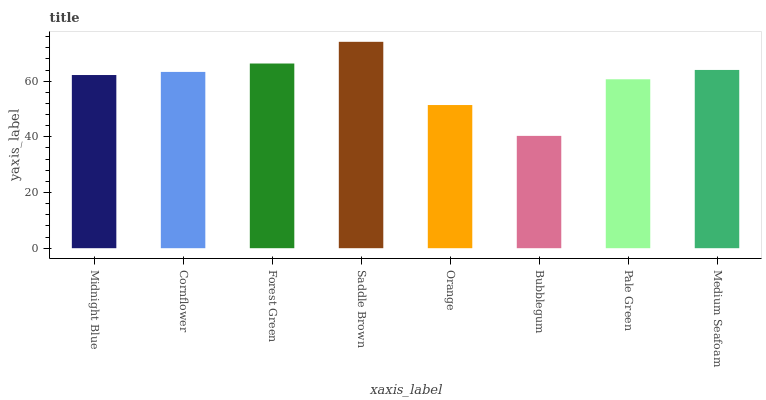Is Bubblegum the minimum?
Answer yes or no. Yes. Is Saddle Brown the maximum?
Answer yes or no. Yes. Is Cornflower the minimum?
Answer yes or no. No. Is Cornflower the maximum?
Answer yes or no. No. Is Cornflower greater than Midnight Blue?
Answer yes or no. Yes. Is Midnight Blue less than Cornflower?
Answer yes or no. Yes. Is Midnight Blue greater than Cornflower?
Answer yes or no. No. Is Cornflower less than Midnight Blue?
Answer yes or no. No. Is Cornflower the high median?
Answer yes or no. Yes. Is Midnight Blue the low median?
Answer yes or no. Yes. Is Forest Green the high median?
Answer yes or no. No. Is Saddle Brown the low median?
Answer yes or no. No. 